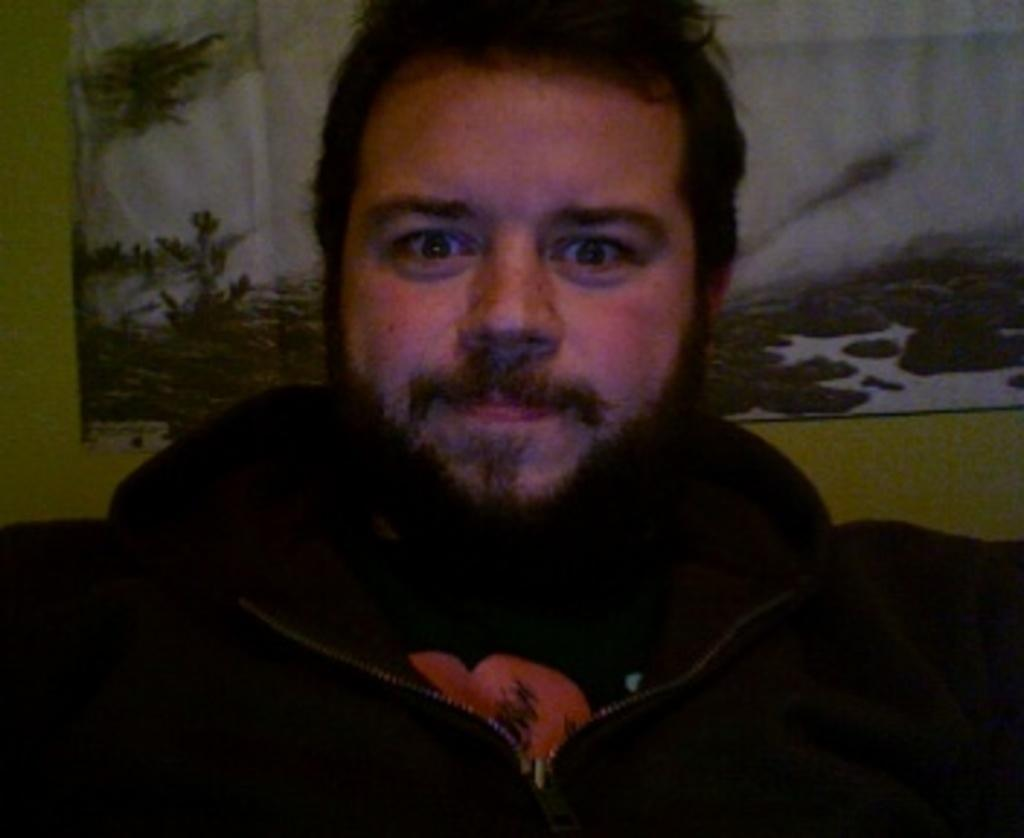Who or what is the main subject in the image? There is a person in the image. What is the person wearing? The person is wearing a black jacket. What can be seen in the background of the image? There is a wall with a picture in the background of the image. What type of brain is visible in the image? There is no brain visible in the image; it features a person wearing a black jacket in front of a wall with a picture. 